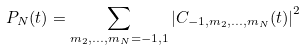<formula> <loc_0><loc_0><loc_500><loc_500>P _ { N } ( t ) = \sum _ { m _ { 2 } , \dots , m _ { N } = - 1 , 1 } \left | C _ { - 1 , m _ { 2 } , \dots , m _ { N } } ( t ) \right | ^ { 2 }</formula> 